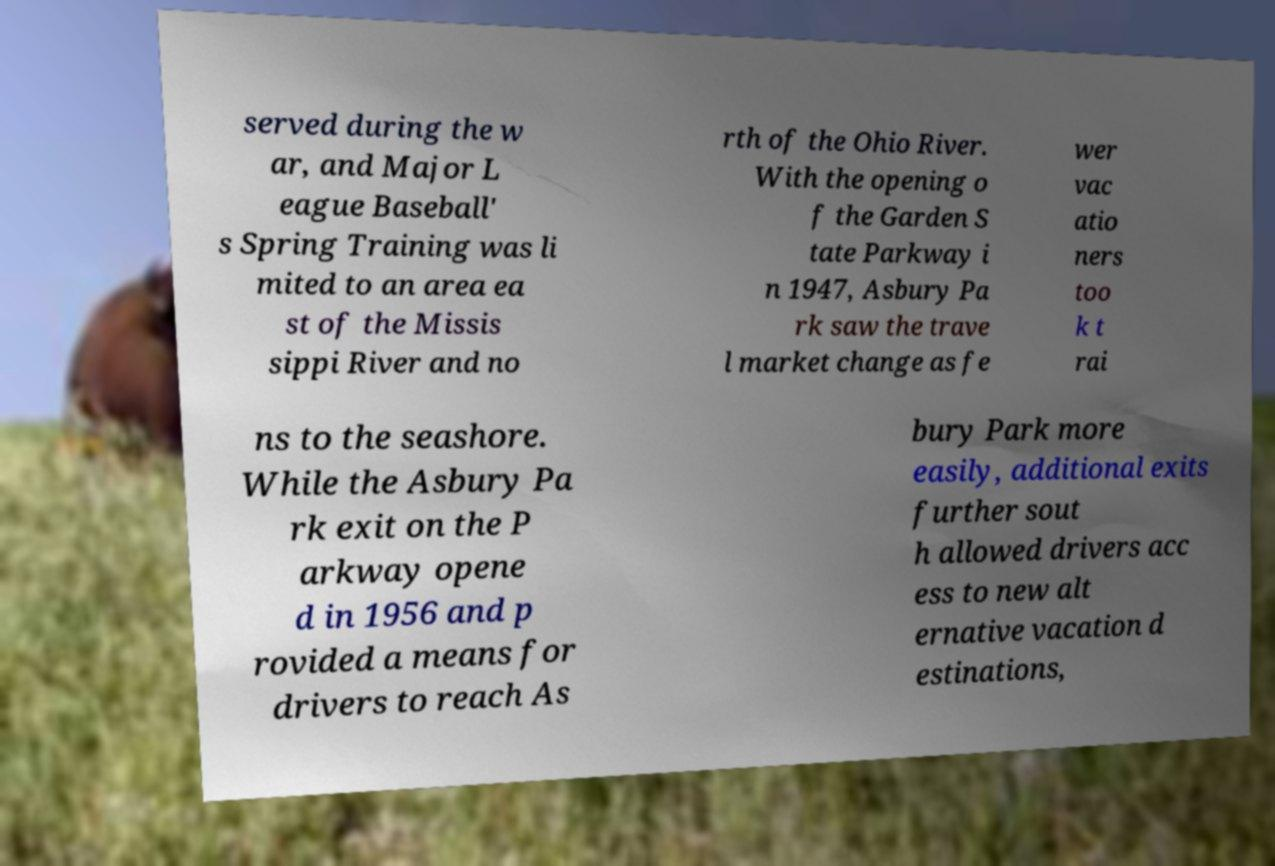What messages or text are displayed in this image? I need them in a readable, typed format. served during the w ar, and Major L eague Baseball' s Spring Training was li mited to an area ea st of the Missis sippi River and no rth of the Ohio River. With the opening o f the Garden S tate Parkway i n 1947, Asbury Pa rk saw the trave l market change as fe wer vac atio ners too k t rai ns to the seashore. While the Asbury Pa rk exit on the P arkway opene d in 1956 and p rovided a means for drivers to reach As bury Park more easily, additional exits further sout h allowed drivers acc ess to new alt ernative vacation d estinations, 